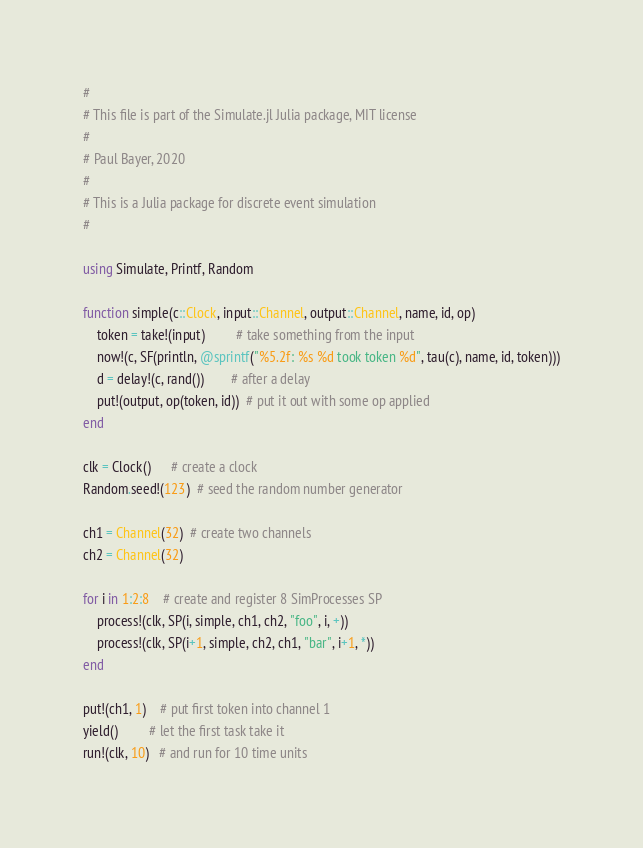Convert code to text. <code><loc_0><loc_0><loc_500><loc_500><_Julia_>#
# This file is part of the Simulate.jl Julia package, MIT license
#
# Paul Bayer, 2020
#
# This is a Julia package for discrete event simulation
#

using Simulate, Printf, Random

function simple(c::Clock, input::Channel, output::Channel, name, id, op)
    token = take!(input)         # take something from the input
    now!(c, SF(println, @sprintf("%5.2f: %s %d took token %d", tau(c), name, id, token)))
    d = delay!(c, rand())        # after a delay
    put!(output, op(token, id))  # put it out with some op applied
end

clk = Clock()      # create a clock
Random.seed!(123)  # seed the random number generator

ch1 = Channel(32)  # create two channels
ch2 = Channel(32)

for i in 1:2:8    # create and register 8 SimProcesses SP
    process!(clk, SP(i, simple, ch1, ch2, "foo", i, +))
    process!(clk, SP(i+1, simple, ch2, ch1, "bar", i+1, *))
end

put!(ch1, 1)    # put first token into channel 1
yield()         # let the first task take it
run!(clk, 10)   # and run for 10 time units
</code> 